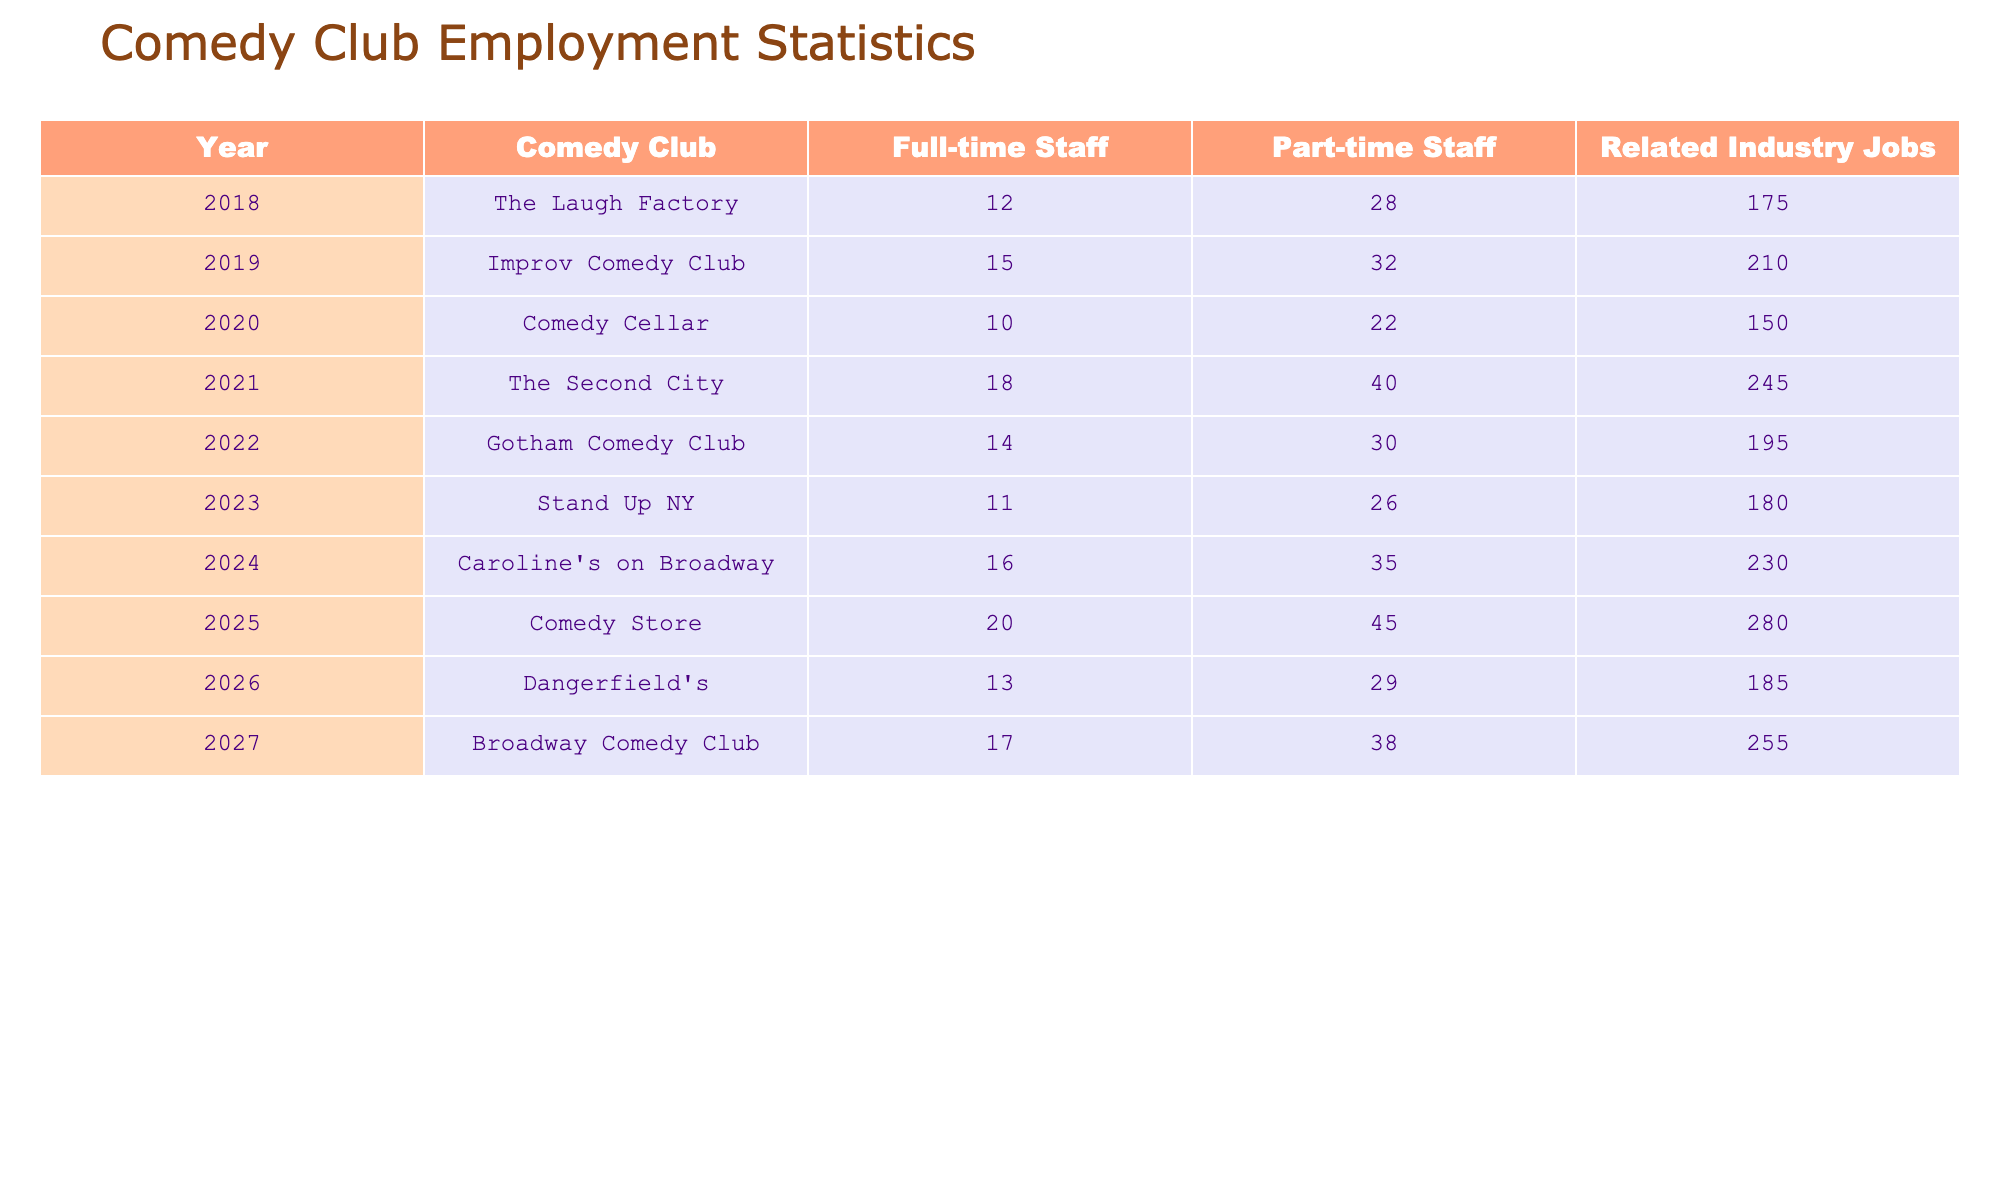What is the total number of full-time staff employed at the comedy clubs in 2023? According to the table, the full-time staff for Stand Up NY in 2023 is 11.
Answer: 11 Which comedy club had the highest number of part-time staff in 2021? The table shows that The Second City had 40 part-time staff in 2021, which is the highest among the listed clubs for that year.
Answer: The Second City What is the average number of related industry jobs from 2018 to 2022? To find the average, we sum the related industry jobs for each year from 2018 to 2022: 175 + 210 + 150 + 245 + 195 = 975. Then, we divide by 5 (the number of years): 975 / 5 = 195.
Answer: 195 Which year had the most significant increase in full-time staff compared to the previous year? We calculate the difference in full-time staff between each pair of consecutive years. The most significant increase is from 2020 (10) to 2021 (18), a difference of 8.
Answer: 2021 Did the total part-time staff increase from 2020 to 2021? In 2020, the part-time staff is 22, and in 2021, it is 40. Subtracting gives us 40 - 22 = 18, so there was an increase.
Answer: Yes What is the total number of jobs (full-time staff, part-time staff, and related industry jobs) at the Comedy Store in 2025? We need to sum the full-time staff (20), part-time staff (45), and related industry jobs (280) for the Comedy Store in 2025. The total is 20 + 45 + 280 = 345.
Answer: 345 What is the change in the number of related industry jobs from 2018 to 2027? We look at the related industry jobs for 2018 (175) and for 2027 (255). The change is calculated as 255 - 175 = 80.
Answer: 80 Which comedy club had the lowest number of full-time staff in 2022? The table indicates that Gotham Comedy Club had 14 full-time staff in 2022, which is the lowest compared to other clubs listed for that year.
Answer: Gotham Comedy Club What is the trend in part-time staff numbers from 2018 to 2025? To identify the trend, we look at the part-time staff numbers over the years: 28, 32, 22, 40, 30, 26, and 45. The overall trend shows fluctuations, but we see an increase in 2025.
Answer: Fluctuating with an increase in 2025 In which year did the comedy clubs have a combined total of 354 staff (full-time + part-time) for the first time? Adding full-time and part-time staff for each year: 2018 (40), 2019 (47), 2020 (32), 2021 (58), 2022 (44), 2023 (37), 2024 (51), 2025 (65), 2026 (42), and 2027 (55). The combined total first exceeds 354 in 2025.
Answer: 2025 